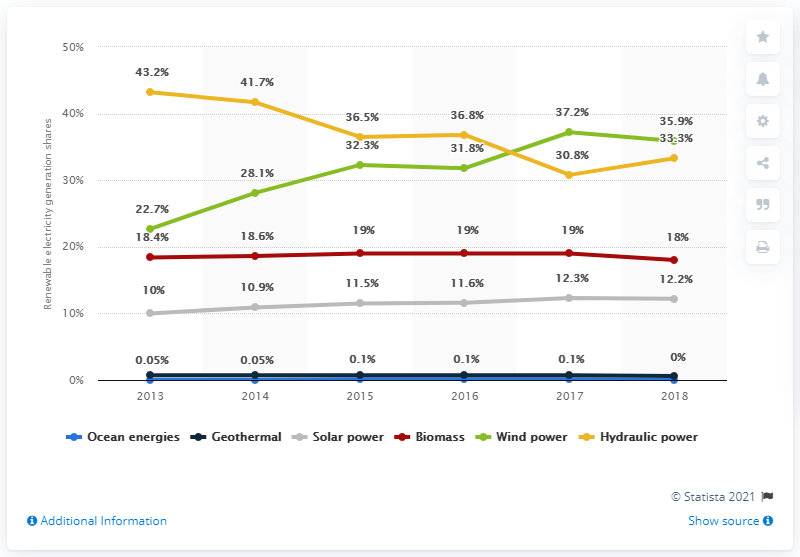Indicate a few pertinent items in this graphic. Wind power reached its peak in 2017. The share of wind power has been higher than that of hydraulic power for at least two years. In 2018, wind power accounted for 35.9% of the total mix. Wind power was the second major renewable source between 2013 and 2016. 